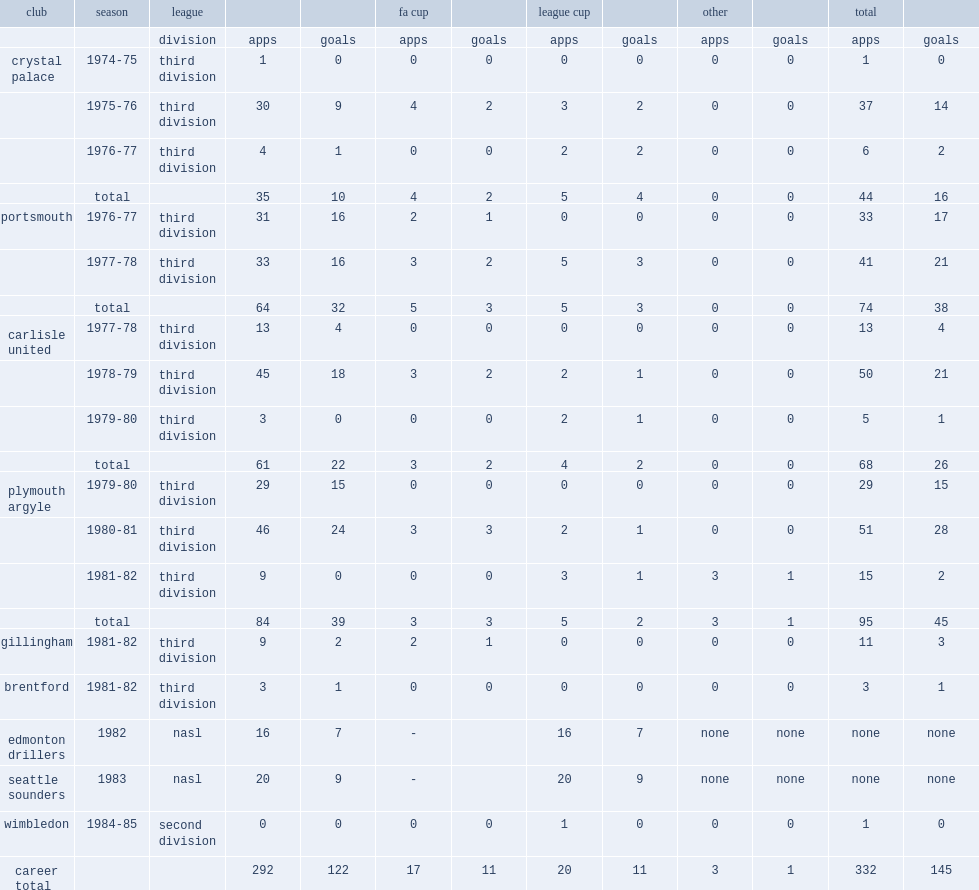Which club did dave kemp play for in 1982? Edmonton drillers. 